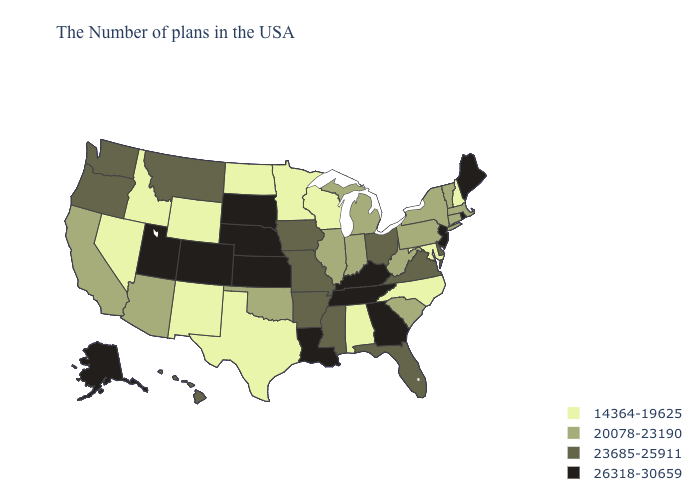Name the states that have a value in the range 20078-23190?
Answer briefly. Massachusetts, Vermont, Connecticut, New York, Pennsylvania, South Carolina, West Virginia, Michigan, Indiana, Illinois, Oklahoma, Arizona, California. Which states hav the highest value in the MidWest?
Write a very short answer. Kansas, Nebraska, South Dakota. Name the states that have a value in the range 23685-25911?
Concise answer only. Delaware, Virginia, Ohio, Florida, Mississippi, Missouri, Arkansas, Iowa, Montana, Washington, Oregon, Hawaii. What is the value of Wyoming?
Keep it brief. 14364-19625. Does Washington have a higher value than Alabama?
Answer briefly. Yes. Name the states that have a value in the range 26318-30659?
Short answer required. Maine, Rhode Island, New Jersey, Georgia, Kentucky, Tennessee, Louisiana, Kansas, Nebraska, South Dakota, Colorado, Utah, Alaska. Name the states that have a value in the range 14364-19625?
Write a very short answer. New Hampshire, Maryland, North Carolina, Alabama, Wisconsin, Minnesota, Texas, North Dakota, Wyoming, New Mexico, Idaho, Nevada. What is the value of Iowa?
Answer briefly. 23685-25911. Name the states that have a value in the range 23685-25911?
Answer briefly. Delaware, Virginia, Ohio, Florida, Mississippi, Missouri, Arkansas, Iowa, Montana, Washington, Oregon, Hawaii. Does the map have missing data?
Concise answer only. No. What is the highest value in the USA?
Write a very short answer. 26318-30659. What is the value of Alabama?
Be succinct. 14364-19625. What is the highest value in the Northeast ?
Give a very brief answer. 26318-30659. Name the states that have a value in the range 23685-25911?
Write a very short answer. Delaware, Virginia, Ohio, Florida, Mississippi, Missouri, Arkansas, Iowa, Montana, Washington, Oregon, Hawaii. Name the states that have a value in the range 23685-25911?
Be succinct. Delaware, Virginia, Ohio, Florida, Mississippi, Missouri, Arkansas, Iowa, Montana, Washington, Oregon, Hawaii. 